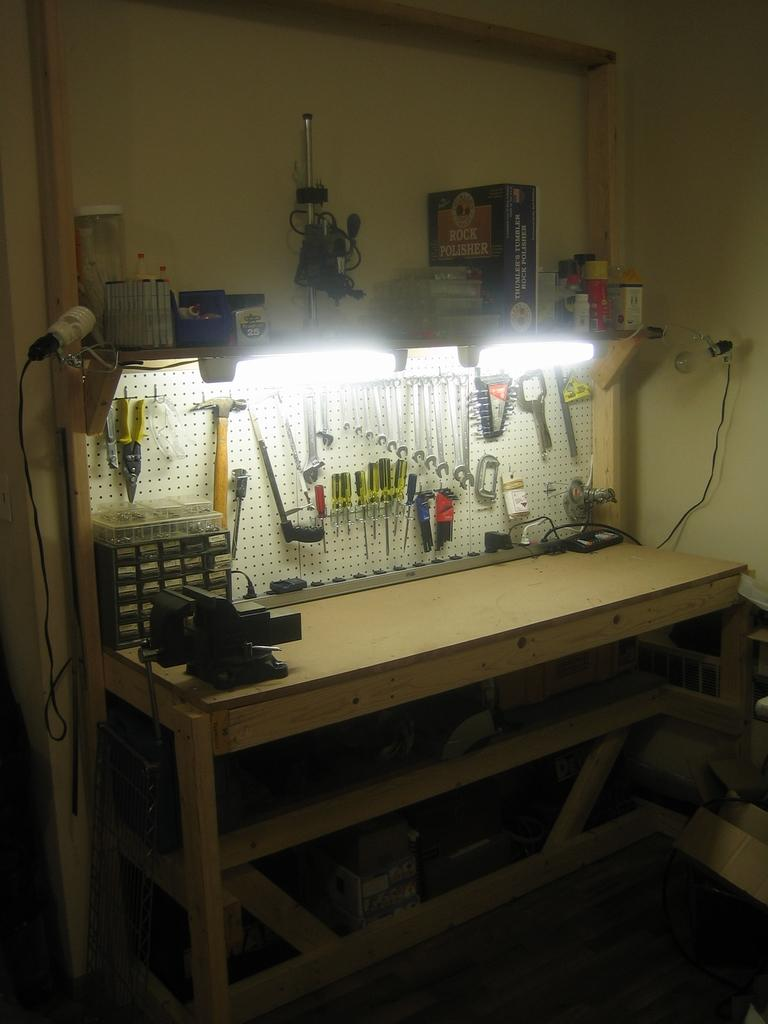What type of table is in the image? There is a wooden table in the image. What can be seen on the table? There are objects on the table. What is hanging on the board in the image? There are tools hanging on a board in the image. What type of lighting is present in the image? There are light bulbs in the image. How many beads are used to create the rice pattern on the table? There is no bead or rice pattern present on the table in the image. 